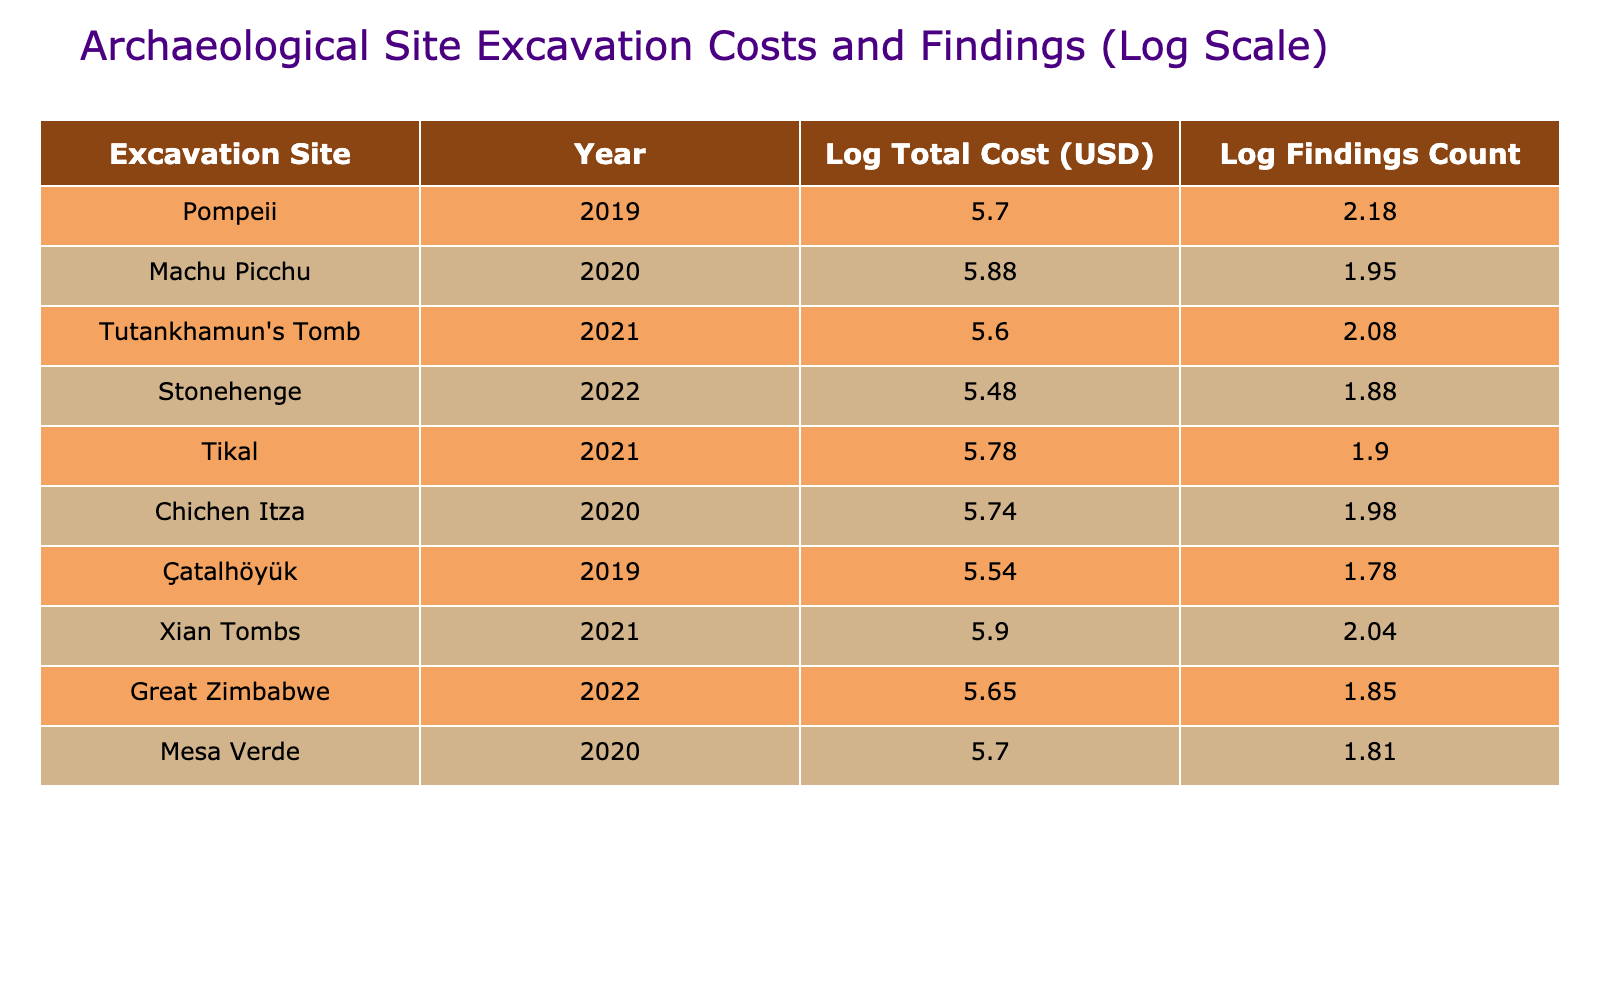What is the log total cost of excavation for the site Machu Picchu? The log total cost for Machu Picchu is shown in the table as 5.87, which is the logarithmic transformation of the total cost of 750,000 USD.
Answer: 5.87 Which archaeological site had the highest log findings count? Looking through the 'Log Findings Count' column in the table, the highest value is for Pompeii with a log findings count of 2.18, indicating it had 150 historical findings.
Answer: 2.18 What is the total log findings count for the sites excavated in 2021? We find the log findings counts for the sites in 2021: Tutankhamun's Tomb (2.08) and Xian Tombs (2.04). Adding these gives 2.08 + 2.04 = 4.12 as the total.
Answer: 4.12 Is the log total cost of excavation for Çatalhöyük greater than the log total cost for Stonehenge? Checking the log total costs, Çatalhöyük is 5.54 while Stonehenge is 5.48. Therefore, Çatalhöyük's log total cost is indeed greater than that of Stonehenge.
Answer: Yes What is the difference between the log total costs of the excavation sites Xian Tombs and Tikal? The log total cost for Xian Tombs is 5.90 and for Tikal it is 5.78. The difference is calculated by 5.90 - 5.78 = 0.12.
Answer: 0.12 What is the average log total cost of excavation across all sites? The log total costs are: 5.70, 5.88, 5.60, 5.48, 5.78, 5.74, 5.54, 5.90, 5.65, and 5.70, making the sum 57.76. Dividing this by 10 (the number of sites) results in an average of 5.78.
Answer: 5.78 How many sites had a historical findings count greater than 80? By analyzing the 'Historical Findings Count' column, we see that the sites with counts greater than 80 are Pompeii (150), Tutankhamun's Tomb (120), Xian Tombs (110), and Chichen Itza (95), totaling four sites.
Answer: 4 Was the log findings count from Mesas Verde higher than 1.70? The log findings count for Mesa Verde is 1.81, which is indeed higher than 1.70, confirming the statement.
Answer: Yes What is the year of excavation with the maximum average log total cost? The years of excavation and their respective log total costs are: 2019 (5.70), 2020 (5.79), 2021 (5.83), and 2022 (5.65). The maximum average corresponds to 2020 with a value of 5.79.
Answer: 2020 